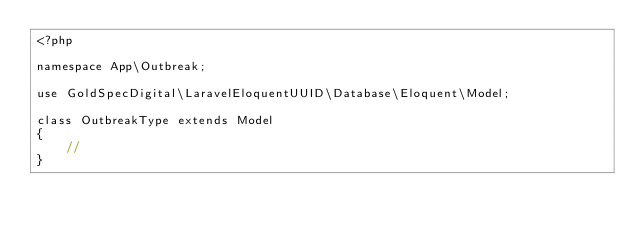Convert code to text. <code><loc_0><loc_0><loc_500><loc_500><_PHP_><?php

namespace App\Outbreak;

use GoldSpecDigital\LaravelEloquentUUID\Database\Eloquent\Model;

class OutbreakType extends Model
{
    //
}
</code> 